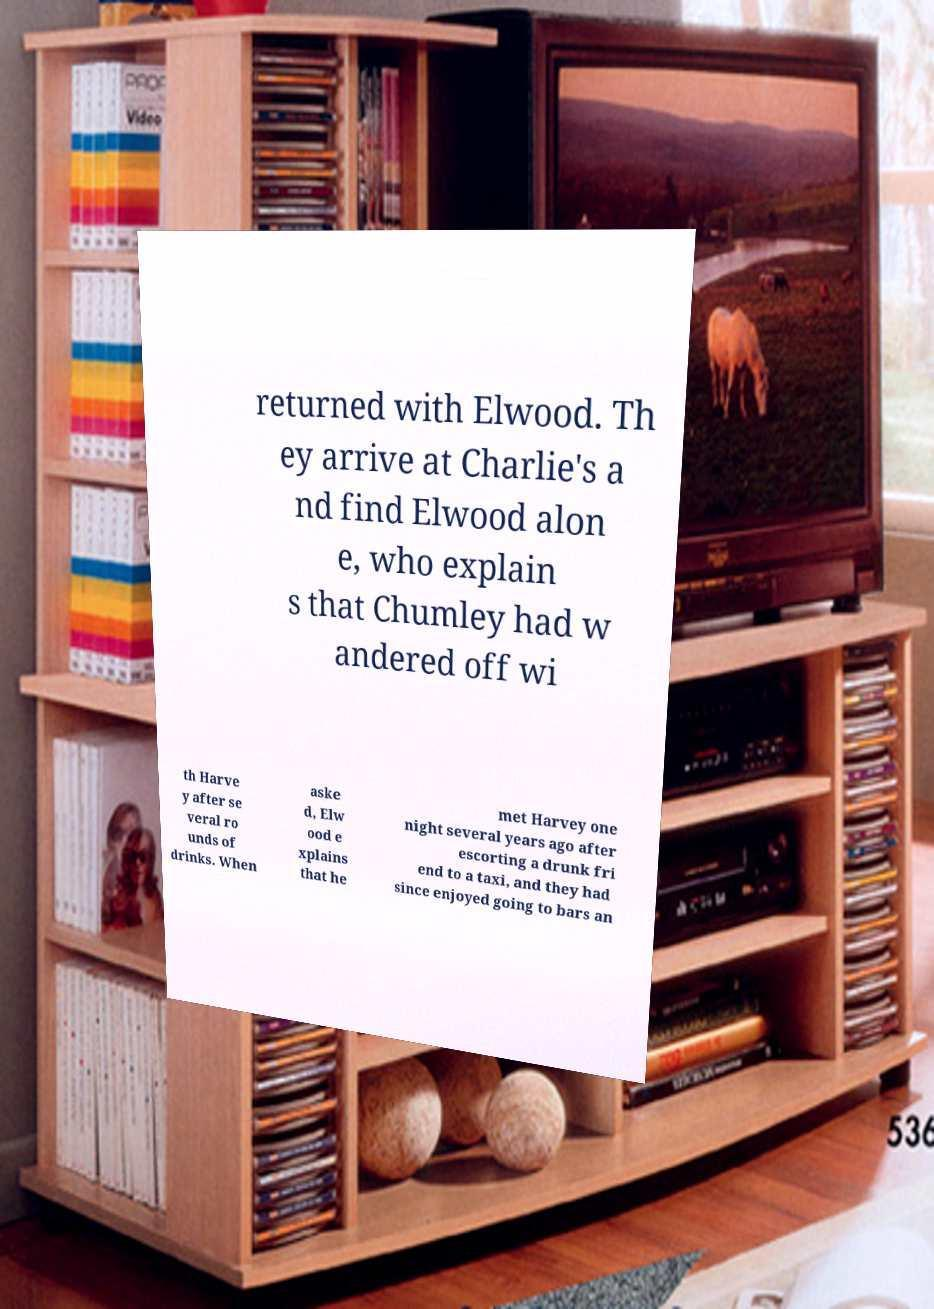Please read and relay the text visible in this image. What does it say? returned with Elwood. Th ey arrive at Charlie's a nd find Elwood alon e, who explain s that Chumley had w andered off wi th Harve y after se veral ro unds of drinks. When aske d, Elw ood e xplains that he met Harvey one night several years ago after escorting a drunk fri end to a taxi, and they had since enjoyed going to bars an 